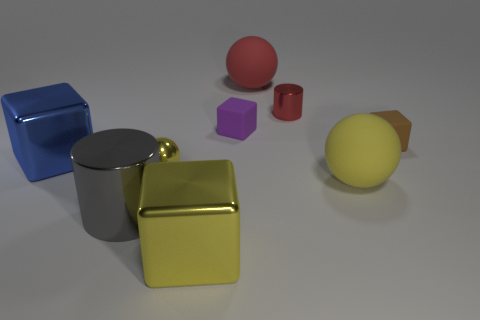How many matte objects are the same color as the big cylinder?
Keep it short and to the point. 0. What number of things are either large yellow things that are left of the yellow matte thing or tiny things that are right of the tiny red cylinder?
Your answer should be very brief. 2. There is a metal cylinder that is to the left of the tiny purple thing; how many yellow spheres are right of it?
Offer a very short reply. 2. There is a ball that is made of the same material as the large gray cylinder; what color is it?
Give a very brief answer. Yellow. Is there a gray shiny cylinder of the same size as the blue block?
Offer a very short reply. Yes. What shape is the purple object that is the same size as the yellow metallic ball?
Ensure brevity in your answer.  Cube. Is there a tiny purple thing that has the same shape as the large blue object?
Offer a terse response. Yes. Does the purple block have the same material as the cylinder that is on the left side of the purple rubber object?
Your answer should be very brief. No. Is there a rubber thing of the same color as the tiny metal ball?
Ensure brevity in your answer.  Yes. What number of other objects are the same material as the large cylinder?
Keep it short and to the point. 4. 